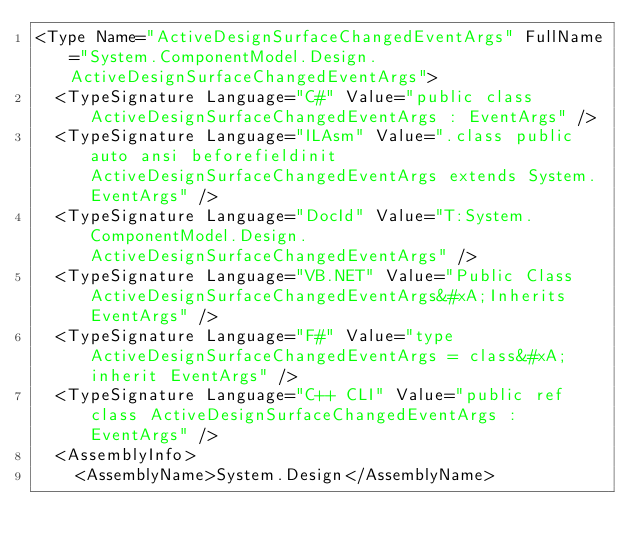Convert code to text. <code><loc_0><loc_0><loc_500><loc_500><_XML_><Type Name="ActiveDesignSurfaceChangedEventArgs" FullName="System.ComponentModel.Design.ActiveDesignSurfaceChangedEventArgs">
  <TypeSignature Language="C#" Value="public class ActiveDesignSurfaceChangedEventArgs : EventArgs" />
  <TypeSignature Language="ILAsm" Value=".class public auto ansi beforefieldinit ActiveDesignSurfaceChangedEventArgs extends System.EventArgs" />
  <TypeSignature Language="DocId" Value="T:System.ComponentModel.Design.ActiveDesignSurfaceChangedEventArgs" />
  <TypeSignature Language="VB.NET" Value="Public Class ActiveDesignSurfaceChangedEventArgs&#xA;Inherits EventArgs" />
  <TypeSignature Language="F#" Value="type ActiveDesignSurfaceChangedEventArgs = class&#xA;    inherit EventArgs" />
  <TypeSignature Language="C++ CLI" Value="public ref class ActiveDesignSurfaceChangedEventArgs : EventArgs" />
  <AssemblyInfo>
    <AssemblyName>System.Design</AssemblyName></code> 